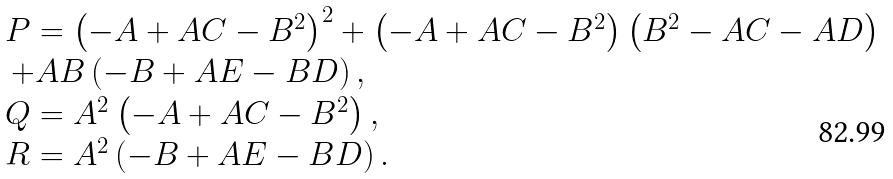Convert formula to latex. <formula><loc_0><loc_0><loc_500><loc_500>\begin{array} { l } P = { \left ( { - A + A C - { B ^ { 2 } } } \right ) ^ { 2 } } + \left ( { - A + A C - { B ^ { 2 } } } \right ) \left ( { { B ^ { 2 } } - A C - A D } \right ) \\ \, + A B \left ( { - B + A E - B D } \right ) , \\ Q = { A ^ { 2 } } \left ( { - A + A C - { B ^ { 2 } } } \right ) , \\ R = { A ^ { 2 } } \left ( { - B + A E - B D } \right ) . \\ \end{array}</formula> 